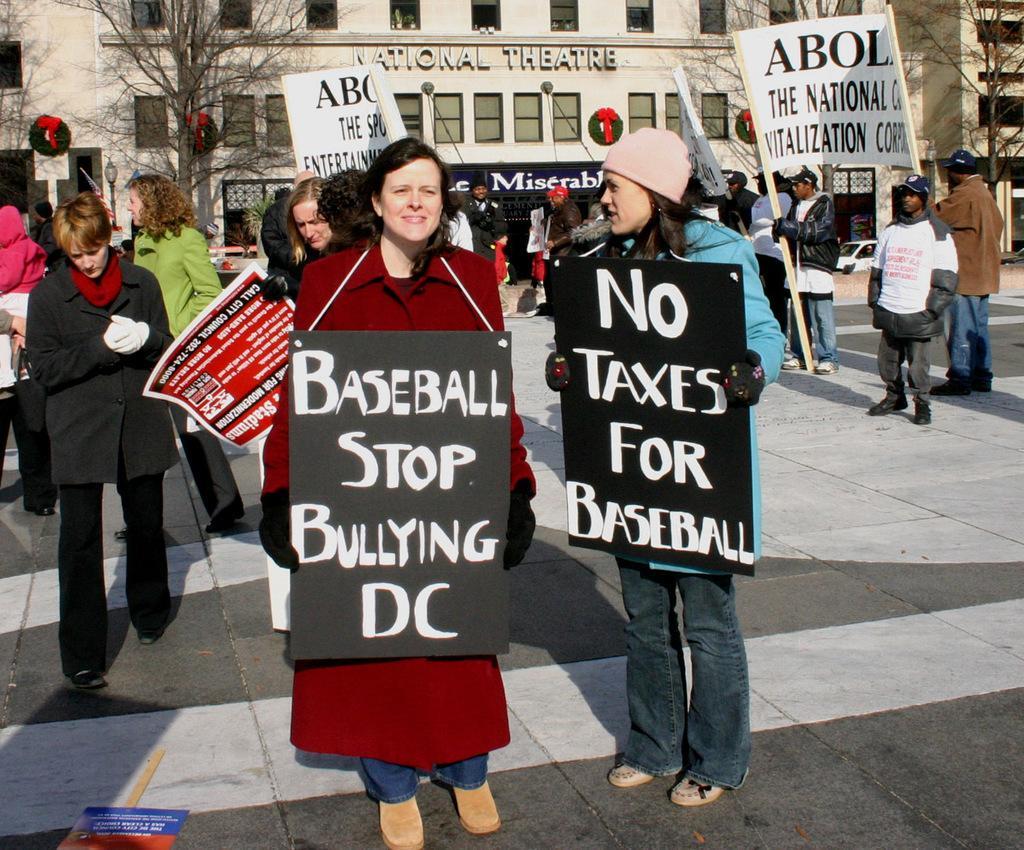How would you summarize this image in a sentence or two? In this picture we can see groups of people, among them few people holding the boards and a few other people holding the sticks with boards. Behind the people, there are trees, buildings, a vehicle and some objects. In the bottom left corner of the image, there is a board on the ground. 